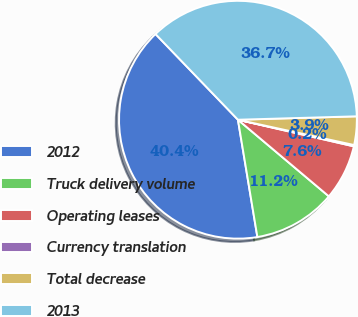Convert chart. <chart><loc_0><loc_0><loc_500><loc_500><pie_chart><fcel>2012<fcel>Truck delivery volume<fcel>Operating leases<fcel>Currency translation<fcel>Total decrease<fcel>2013<nl><fcel>40.42%<fcel>11.24%<fcel>7.55%<fcel>0.18%<fcel>3.87%<fcel>36.73%<nl></chart> 